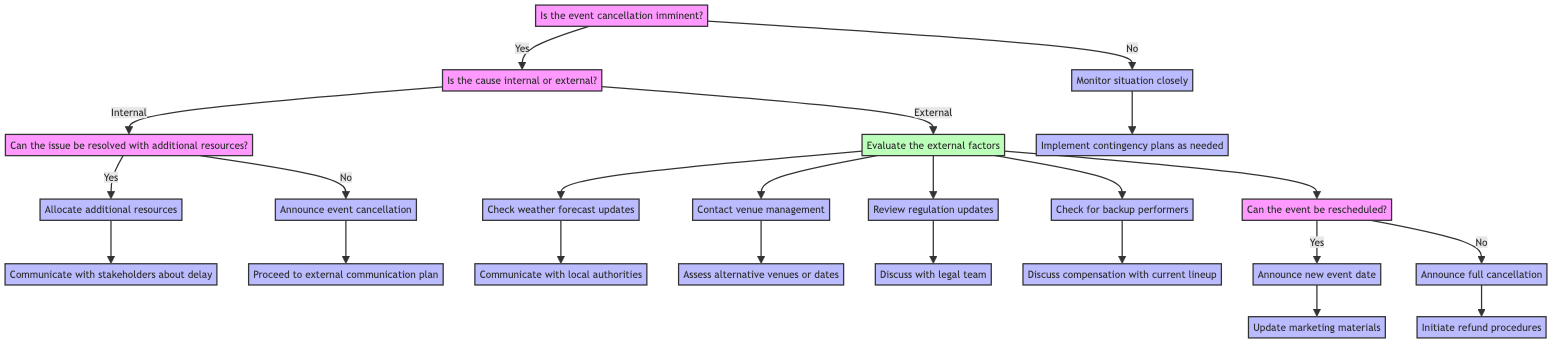Is the first question in the decision tree? The first question in the diagram is "Is the event cancellation imminent?". It is located at the top of the tree, indicating the starting point for the decision-making process.
Answer: Yes What happens if the event cancellation is not imminent? According to the diagram, if the answer to the first question is "No", the action taken is to "Monitor situation closely", indicating ongoing observation rather than immediate action.
Answer: Monitor situation closely How many actions are taken if the cause of cancellation is internal and cannot be resolved? If the cause is internal and cannot be resolved, the action taken is "Announce event cancellation" followed by "Proceed to external communication plan". Thus, there are two actions involved in this scenario.
Answer: Two What should be done after checking the weather forecast updates? After checking the weather forecast updates, the next step is to "Communicate with local authorities". This indicates the action to take based on the weather analysis.
Answer: Communicate with local authorities What is the final decision if the event cannot be rescheduled? If the decision from the question "Can the event be rescheduled?" is "No", the final action is to "Announce full cancellation", indicating that the event will not take place at all.
Answer: Announce full cancellation What is the action taken after allocating additional resources? After allocating additional resources, the next step is to "Communicate with stakeholders about delay", showing the need to inform all relevant parties of the situation following resource allocation.
Answer: Communicate with stakeholders about delay Is there a step for checking backup performers? Yes, there is a specific action for checking backup performers. If the external cause of cancellation is performers being unavailable, then the action is to "Check for backup performers".
Answer: Yes What is the action related to government regulation updates? The action related to government regulation updates is to "Review regulation updates", indicating a need to ensure compliance with any new laws or regulations that could affect the event.
Answer: Review regulation updates 